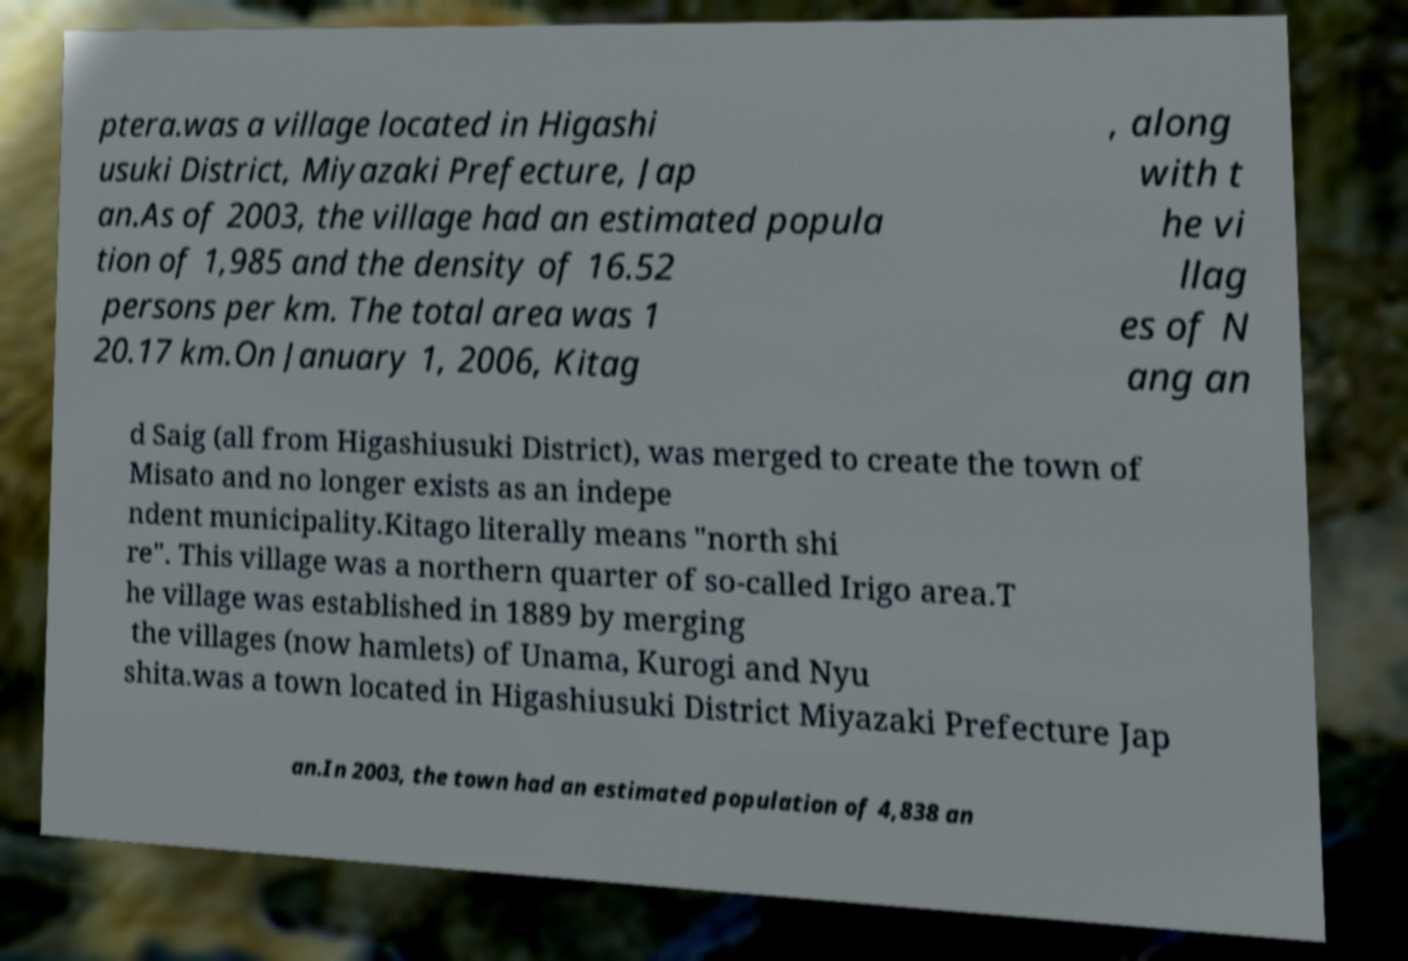Could you extract and type out the text from this image? ptera.was a village located in Higashi usuki District, Miyazaki Prefecture, Jap an.As of 2003, the village had an estimated popula tion of 1,985 and the density of 16.52 persons per km. The total area was 1 20.17 km.On January 1, 2006, Kitag , along with t he vi llag es of N ang an d Saig (all from Higashiusuki District), was merged to create the town of Misato and no longer exists as an indepe ndent municipality.Kitago literally means "north shi re". This village was a northern quarter of so-called Irigo area.T he village was established in 1889 by merging the villages (now hamlets) of Unama, Kurogi and Nyu shita.was a town located in Higashiusuki District Miyazaki Prefecture Jap an.In 2003, the town had an estimated population of 4,838 an 